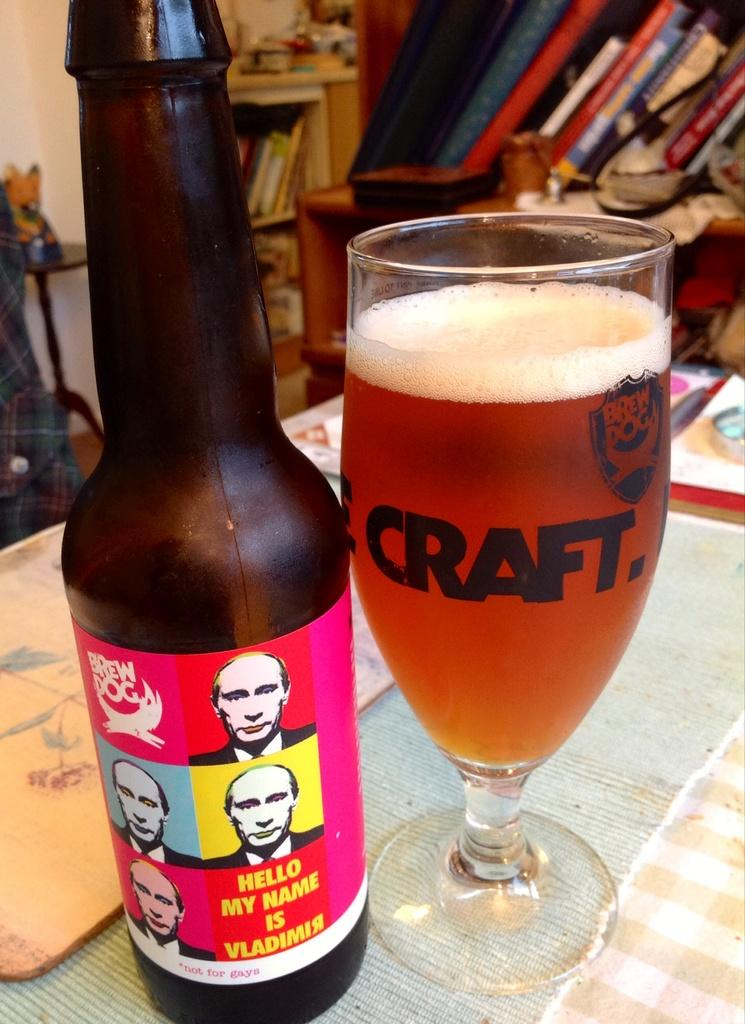Provide a one-sentence caption for the provided image. A brown beer bottle with brew dog and five pictures of Putin with the words hello my name is Vladimir under them and a glass full of beer beside it. 